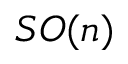Convert formula to latex. <formula><loc_0><loc_0><loc_500><loc_500>S O ( n )</formula> 